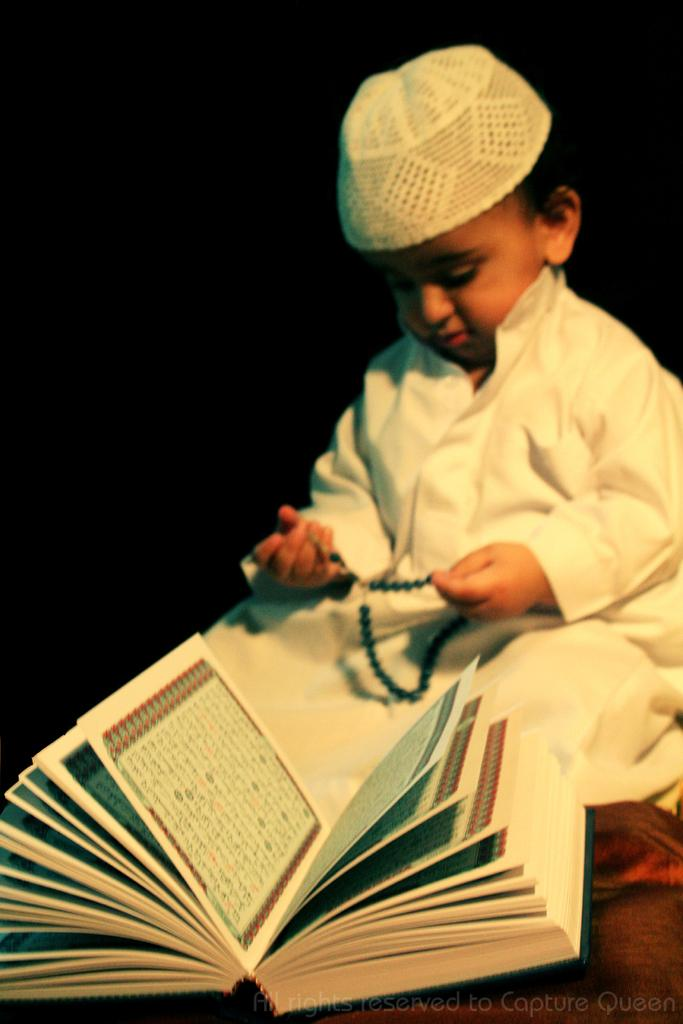What is the main subject of the picture? The main subject of the picture is a kid. What is the kid doing in the picture? The kid is sitting in the picture. What is the kid doing in front of? The kid is in front of a book. What is the kid wearing? The kid is wearing a white dress and a cap on his head. How would you describe the background of the image? The background of the image is dark. Can you tell me how many fish are swimming in the background of the image? There are no fish present in the image; the background is dark. Does the existence of the kid in the image prove the existence of a parallel universe? The presence of the kid in the image does not prove the existence of a parallel universe, as the image is a representation of a real-world scenario. 